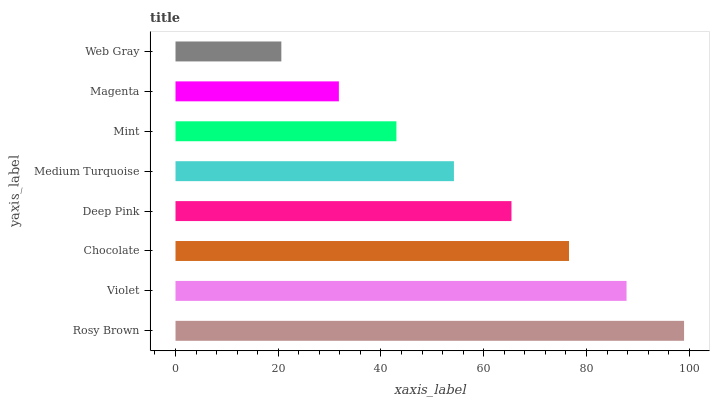Is Web Gray the minimum?
Answer yes or no. Yes. Is Rosy Brown the maximum?
Answer yes or no. Yes. Is Violet the minimum?
Answer yes or no. No. Is Violet the maximum?
Answer yes or no. No. Is Rosy Brown greater than Violet?
Answer yes or no. Yes. Is Violet less than Rosy Brown?
Answer yes or no. Yes. Is Violet greater than Rosy Brown?
Answer yes or no. No. Is Rosy Brown less than Violet?
Answer yes or no. No. Is Deep Pink the high median?
Answer yes or no. Yes. Is Medium Turquoise the low median?
Answer yes or no. Yes. Is Violet the high median?
Answer yes or no. No. Is Violet the low median?
Answer yes or no. No. 